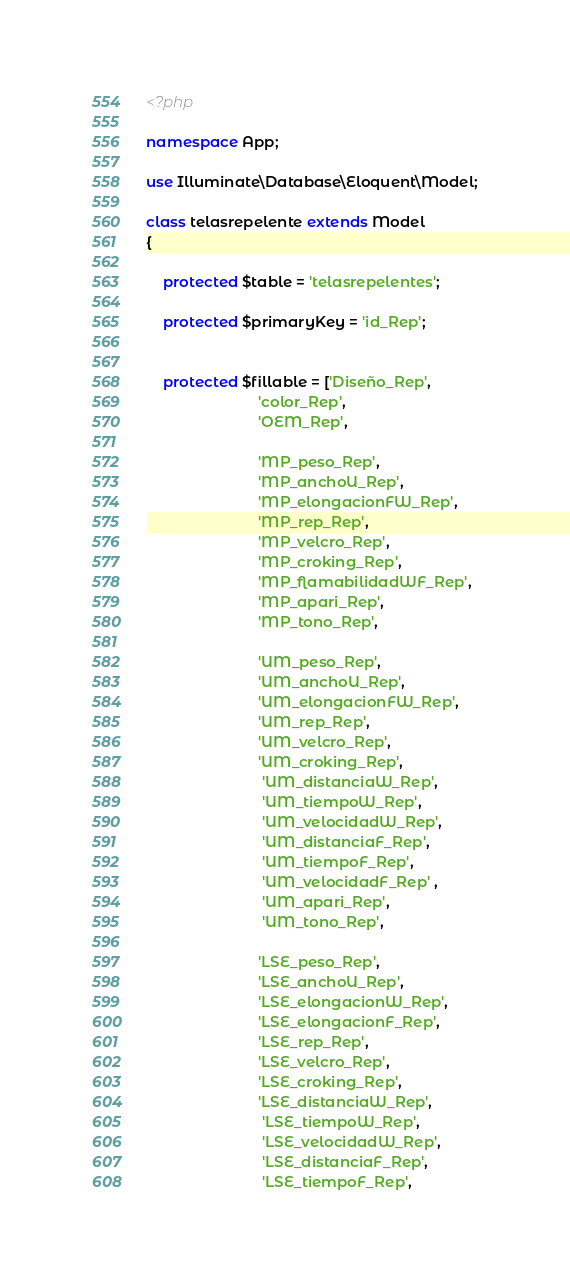<code> <loc_0><loc_0><loc_500><loc_500><_PHP_><?php

namespace App;

use Illuminate\Database\Eloquent\Model;

class telasrepelente extends Model
{

	protected $table = 'telasrepelentes';

	protected $primaryKey = 'id_Rep';


	protected $fillable = ['Diseño_Rep', 
						   'color_Rep', 
						   'OEM_Rep',

						   'MP_peso_Rep', 
						   'MP_anchoU_Rep', 
						   'MP_elongacionFW_Rep', 
						   'MP_rep_Rep', 
						   'MP_velcro_Rep', 
						   'MP_croking_Rep', 
						   'MP_flamabilidadWF_Rep', 
						   'MP_apari_Rep', 
						   'MP_tono_Rep', 

						   'UM_peso_Rep', 
						   'UM_anchoU_Rep', 
						   'UM_elongacionFW_Rep', 
						   'UM_rep_Rep', 
						   'UM_velcro_Rep', 
						   'UM_croking_Rep',
						    'UM_distanciaW_Rep',
							'UM_tiempoW_Rep',
							'UM_velocidadW_Rep',
							'UM_distanciaF_Rep',
							'UM_tiempoF_Rep',
							'UM_velocidadF_Rep' , 
							'UM_apari_Rep', 
							'UM_tono_Rep', 

						   'LSE_peso_Rep', 
						   'LSE_anchoU_Rep', 
						   'LSE_elongacionW_Rep', 
						   'LSE_elongacionF_Rep', 
						   'LSE_rep_Rep', 
						   'LSE_velcro_Rep', 
						   'LSE_croking_Rep', 
						   'LSE_distanciaW_Rep',
							'LSE_tiempoW_Rep',
							'LSE_velocidadW_Rep',
							'LSE_distanciaF_Rep',
							'LSE_tiempoF_Rep',</code> 